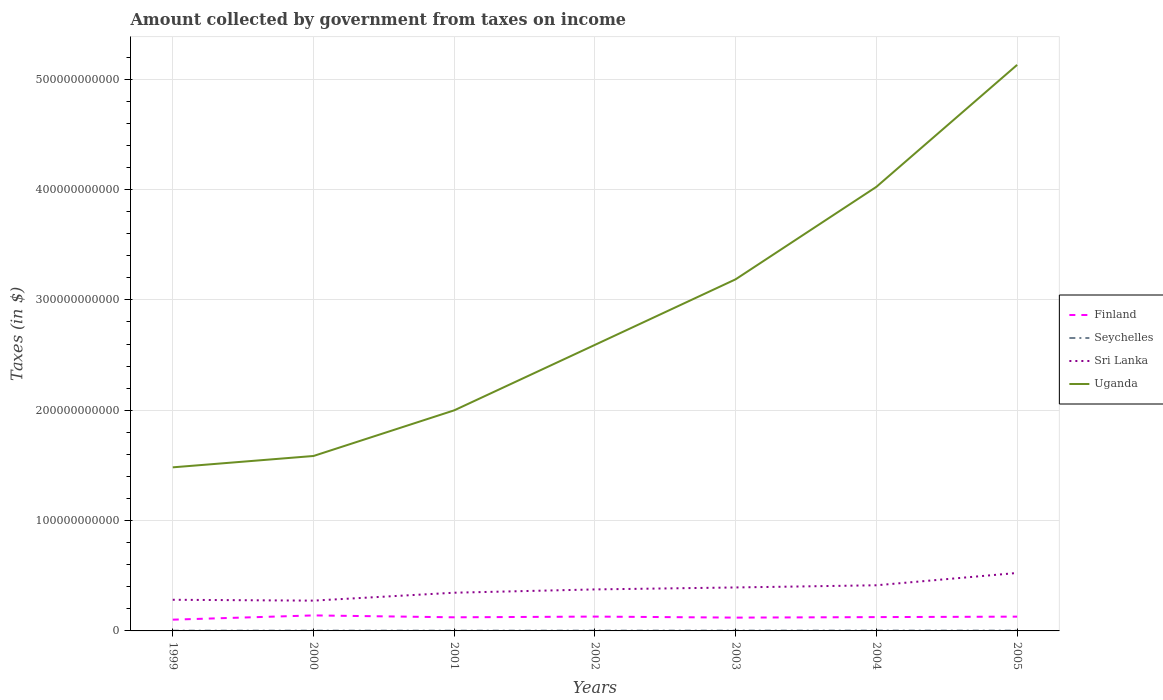Does the line corresponding to Uganda intersect with the line corresponding to Seychelles?
Provide a succinct answer. No. Across all years, what is the maximum amount collected by government from taxes on income in Finland?
Offer a very short reply. 1.02e+1. In which year was the amount collected by government from taxes on income in Sri Lanka maximum?
Keep it short and to the point. 2000. What is the total amount collected by government from taxes on income in Sri Lanka in the graph?
Offer a terse response. -9.39e+09. What is the difference between the highest and the second highest amount collected by government from taxes on income in Seychelles?
Make the answer very short. 7.53e+07. What is the difference between two consecutive major ticks on the Y-axis?
Provide a short and direct response. 1.00e+11. Where does the legend appear in the graph?
Ensure brevity in your answer.  Center right. What is the title of the graph?
Your answer should be very brief. Amount collected by government from taxes on income. What is the label or title of the X-axis?
Keep it short and to the point. Years. What is the label or title of the Y-axis?
Offer a terse response. Taxes (in $). What is the Taxes (in $) in Finland in 1999?
Give a very brief answer. 1.02e+1. What is the Taxes (in $) in Seychelles in 1999?
Offer a very short reply. 2.23e+08. What is the Taxes (in $) of Sri Lanka in 1999?
Offer a terse response. 2.82e+1. What is the Taxes (in $) in Uganda in 1999?
Provide a short and direct response. 1.48e+11. What is the Taxes (in $) in Finland in 2000?
Your answer should be compact. 1.41e+1. What is the Taxes (in $) in Seychelles in 2000?
Your response must be concise. 2.44e+08. What is the Taxes (in $) in Sri Lanka in 2000?
Your answer should be compact. 2.75e+1. What is the Taxes (in $) of Uganda in 2000?
Provide a succinct answer. 1.59e+11. What is the Taxes (in $) of Finland in 2001?
Keep it short and to the point. 1.23e+1. What is the Taxes (in $) in Seychelles in 2001?
Keep it short and to the point. 2.28e+08. What is the Taxes (in $) in Sri Lanka in 2001?
Ensure brevity in your answer.  3.46e+1. What is the Taxes (in $) of Uganda in 2001?
Make the answer very short. 2.00e+11. What is the Taxes (in $) of Finland in 2002?
Your response must be concise. 1.30e+1. What is the Taxes (in $) in Seychelles in 2002?
Provide a succinct answer. 2.53e+08. What is the Taxes (in $) in Sri Lanka in 2002?
Your answer should be very brief. 3.76e+1. What is the Taxes (in $) in Uganda in 2002?
Ensure brevity in your answer.  2.59e+11. What is the Taxes (in $) in Finland in 2003?
Your response must be concise. 1.21e+1. What is the Taxes (in $) of Seychelles in 2003?
Your response must be concise. 2.77e+08. What is the Taxes (in $) of Sri Lanka in 2003?
Your answer should be compact. 3.94e+1. What is the Taxes (in $) in Uganda in 2003?
Your answer should be very brief. 3.19e+11. What is the Taxes (in $) of Finland in 2004?
Your response must be concise. 1.25e+1. What is the Taxes (in $) in Seychelles in 2004?
Offer a terse response. 2.98e+08. What is the Taxes (in $) of Sri Lanka in 2004?
Offer a very short reply. 4.14e+1. What is the Taxes (in $) in Uganda in 2004?
Your answer should be very brief. 4.02e+11. What is the Taxes (in $) in Finland in 2005?
Ensure brevity in your answer.  1.29e+1. What is the Taxes (in $) in Seychelles in 2005?
Provide a succinct answer. 2.79e+08. What is the Taxes (in $) in Sri Lanka in 2005?
Give a very brief answer. 5.25e+1. What is the Taxes (in $) in Uganda in 2005?
Make the answer very short. 5.13e+11. Across all years, what is the maximum Taxes (in $) in Finland?
Offer a very short reply. 1.41e+1. Across all years, what is the maximum Taxes (in $) in Seychelles?
Make the answer very short. 2.98e+08. Across all years, what is the maximum Taxes (in $) in Sri Lanka?
Your answer should be very brief. 5.25e+1. Across all years, what is the maximum Taxes (in $) of Uganda?
Give a very brief answer. 5.13e+11. Across all years, what is the minimum Taxes (in $) of Finland?
Give a very brief answer. 1.02e+1. Across all years, what is the minimum Taxes (in $) in Seychelles?
Provide a succinct answer. 2.23e+08. Across all years, what is the minimum Taxes (in $) of Sri Lanka?
Keep it short and to the point. 2.75e+1. Across all years, what is the minimum Taxes (in $) in Uganda?
Provide a succinct answer. 1.48e+11. What is the total Taxes (in $) of Finland in the graph?
Your response must be concise. 8.71e+1. What is the total Taxes (in $) of Seychelles in the graph?
Keep it short and to the point. 1.80e+09. What is the total Taxes (in $) in Sri Lanka in the graph?
Your answer should be very brief. 2.61e+11. What is the total Taxes (in $) in Uganda in the graph?
Offer a very short reply. 2.00e+12. What is the difference between the Taxes (in $) in Finland in 1999 and that in 2000?
Keep it short and to the point. -3.85e+09. What is the difference between the Taxes (in $) in Seychelles in 1999 and that in 2000?
Give a very brief answer. -2.12e+07. What is the difference between the Taxes (in $) of Sri Lanka in 1999 and that in 2000?
Your response must be concise. 7.70e+08. What is the difference between the Taxes (in $) of Uganda in 1999 and that in 2000?
Your response must be concise. -1.03e+1. What is the difference between the Taxes (in $) of Finland in 1999 and that in 2001?
Ensure brevity in your answer.  -2.14e+09. What is the difference between the Taxes (in $) of Seychelles in 1999 and that in 2001?
Your response must be concise. -5.10e+06. What is the difference between the Taxes (in $) in Sri Lanka in 1999 and that in 2001?
Provide a succinct answer. -6.41e+09. What is the difference between the Taxes (in $) of Uganda in 1999 and that in 2001?
Your response must be concise. -5.17e+1. What is the difference between the Taxes (in $) in Finland in 1999 and that in 2002?
Keep it short and to the point. -2.79e+09. What is the difference between the Taxes (in $) in Seychelles in 1999 and that in 2002?
Offer a terse response. -3.00e+07. What is the difference between the Taxes (in $) in Sri Lanka in 1999 and that in 2002?
Offer a terse response. -9.39e+09. What is the difference between the Taxes (in $) in Uganda in 1999 and that in 2002?
Make the answer very short. -1.11e+11. What is the difference between the Taxes (in $) in Finland in 1999 and that in 2003?
Your response must be concise. -1.86e+09. What is the difference between the Taxes (in $) of Seychelles in 1999 and that in 2003?
Offer a terse response. -5.35e+07. What is the difference between the Taxes (in $) in Sri Lanka in 1999 and that in 2003?
Give a very brief answer. -1.12e+1. What is the difference between the Taxes (in $) of Uganda in 1999 and that in 2003?
Your answer should be compact. -1.70e+11. What is the difference between the Taxes (in $) in Finland in 1999 and that in 2004?
Provide a succinct answer. -2.32e+09. What is the difference between the Taxes (in $) in Seychelles in 1999 and that in 2004?
Your answer should be very brief. -7.53e+07. What is the difference between the Taxes (in $) of Sri Lanka in 1999 and that in 2004?
Offer a very short reply. -1.31e+1. What is the difference between the Taxes (in $) in Uganda in 1999 and that in 2004?
Your response must be concise. -2.54e+11. What is the difference between the Taxes (in $) in Finland in 1999 and that in 2005?
Your answer should be very brief. -2.74e+09. What is the difference between the Taxes (in $) in Seychelles in 1999 and that in 2005?
Give a very brief answer. -5.63e+07. What is the difference between the Taxes (in $) in Sri Lanka in 1999 and that in 2005?
Your answer should be compact. -2.43e+1. What is the difference between the Taxes (in $) of Uganda in 1999 and that in 2005?
Make the answer very short. -3.65e+11. What is the difference between the Taxes (in $) of Finland in 2000 and that in 2001?
Offer a very short reply. 1.72e+09. What is the difference between the Taxes (in $) of Seychelles in 2000 and that in 2001?
Your response must be concise. 1.61e+07. What is the difference between the Taxes (in $) of Sri Lanka in 2000 and that in 2001?
Give a very brief answer. -7.18e+09. What is the difference between the Taxes (in $) of Uganda in 2000 and that in 2001?
Provide a short and direct response. -4.14e+1. What is the difference between the Taxes (in $) in Finland in 2000 and that in 2002?
Provide a short and direct response. 1.07e+09. What is the difference between the Taxes (in $) in Seychelles in 2000 and that in 2002?
Ensure brevity in your answer.  -8.80e+06. What is the difference between the Taxes (in $) of Sri Lanka in 2000 and that in 2002?
Offer a very short reply. -1.02e+1. What is the difference between the Taxes (in $) in Uganda in 2000 and that in 2002?
Your response must be concise. -1.01e+11. What is the difference between the Taxes (in $) in Finland in 2000 and that in 2003?
Your response must be concise. 1.99e+09. What is the difference between the Taxes (in $) of Seychelles in 2000 and that in 2003?
Your answer should be compact. -3.23e+07. What is the difference between the Taxes (in $) in Sri Lanka in 2000 and that in 2003?
Your answer should be compact. -1.19e+1. What is the difference between the Taxes (in $) in Uganda in 2000 and that in 2003?
Keep it short and to the point. -1.60e+11. What is the difference between the Taxes (in $) of Finland in 2000 and that in 2004?
Provide a succinct answer. 1.54e+09. What is the difference between the Taxes (in $) in Seychelles in 2000 and that in 2004?
Keep it short and to the point. -5.41e+07. What is the difference between the Taxes (in $) of Sri Lanka in 2000 and that in 2004?
Offer a very short reply. -1.39e+1. What is the difference between the Taxes (in $) in Uganda in 2000 and that in 2004?
Offer a terse response. -2.44e+11. What is the difference between the Taxes (in $) of Finland in 2000 and that in 2005?
Offer a very short reply. 1.12e+09. What is the difference between the Taxes (in $) of Seychelles in 2000 and that in 2005?
Offer a very short reply. -3.51e+07. What is the difference between the Taxes (in $) of Sri Lanka in 2000 and that in 2005?
Offer a very short reply. -2.51e+1. What is the difference between the Taxes (in $) in Uganda in 2000 and that in 2005?
Your answer should be very brief. -3.54e+11. What is the difference between the Taxes (in $) of Finland in 2001 and that in 2002?
Your response must be concise. -6.49e+08. What is the difference between the Taxes (in $) of Seychelles in 2001 and that in 2002?
Your answer should be very brief. -2.49e+07. What is the difference between the Taxes (in $) in Sri Lanka in 2001 and that in 2002?
Offer a terse response. -2.98e+09. What is the difference between the Taxes (in $) in Uganda in 2001 and that in 2002?
Offer a terse response. -5.93e+1. What is the difference between the Taxes (in $) of Finland in 2001 and that in 2003?
Your answer should be compact. 2.74e+08. What is the difference between the Taxes (in $) in Seychelles in 2001 and that in 2003?
Offer a very short reply. -4.84e+07. What is the difference between the Taxes (in $) of Sri Lanka in 2001 and that in 2003?
Your response must be concise. -4.76e+09. What is the difference between the Taxes (in $) of Uganda in 2001 and that in 2003?
Keep it short and to the point. -1.19e+11. What is the difference between the Taxes (in $) in Finland in 2001 and that in 2004?
Offer a very short reply. -1.82e+08. What is the difference between the Taxes (in $) in Seychelles in 2001 and that in 2004?
Make the answer very short. -7.02e+07. What is the difference between the Taxes (in $) in Sri Lanka in 2001 and that in 2004?
Offer a very short reply. -6.74e+09. What is the difference between the Taxes (in $) in Uganda in 2001 and that in 2004?
Offer a terse response. -2.03e+11. What is the difference between the Taxes (in $) in Finland in 2001 and that in 2005?
Your answer should be compact. -6.02e+08. What is the difference between the Taxes (in $) of Seychelles in 2001 and that in 2005?
Provide a short and direct response. -5.12e+07. What is the difference between the Taxes (in $) in Sri Lanka in 2001 and that in 2005?
Give a very brief answer. -1.79e+1. What is the difference between the Taxes (in $) in Uganda in 2001 and that in 2005?
Keep it short and to the point. -3.13e+11. What is the difference between the Taxes (in $) of Finland in 2002 and that in 2003?
Your answer should be compact. 9.24e+08. What is the difference between the Taxes (in $) of Seychelles in 2002 and that in 2003?
Provide a short and direct response. -2.35e+07. What is the difference between the Taxes (in $) in Sri Lanka in 2002 and that in 2003?
Provide a short and direct response. -1.78e+09. What is the difference between the Taxes (in $) of Uganda in 2002 and that in 2003?
Give a very brief answer. -5.94e+1. What is the difference between the Taxes (in $) in Finland in 2002 and that in 2004?
Your answer should be very brief. 4.68e+08. What is the difference between the Taxes (in $) in Seychelles in 2002 and that in 2004?
Offer a very short reply. -4.53e+07. What is the difference between the Taxes (in $) in Sri Lanka in 2002 and that in 2004?
Provide a succinct answer. -3.75e+09. What is the difference between the Taxes (in $) in Uganda in 2002 and that in 2004?
Your answer should be compact. -1.43e+11. What is the difference between the Taxes (in $) in Finland in 2002 and that in 2005?
Give a very brief answer. 4.75e+07. What is the difference between the Taxes (in $) of Seychelles in 2002 and that in 2005?
Keep it short and to the point. -2.63e+07. What is the difference between the Taxes (in $) in Sri Lanka in 2002 and that in 2005?
Offer a very short reply. -1.49e+1. What is the difference between the Taxes (in $) in Uganda in 2002 and that in 2005?
Your answer should be very brief. -2.54e+11. What is the difference between the Taxes (in $) of Finland in 2003 and that in 2004?
Make the answer very short. -4.56e+08. What is the difference between the Taxes (in $) in Seychelles in 2003 and that in 2004?
Offer a very short reply. -2.18e+07. What is the difference between the Taxes (in $) of Sri Lanka in 2003 and that in 2004?
Offer a very short reply. -1.98e+09. What is the difference between the Taxes (in $) of Uganda in 2003 and that in 2004?
Your answer should be compact. -8.38e+1. What is the difference between the Taxes (in $) of Finland in 2003 and that in 2005?
Provide a succinct answer. -8.76e+08. What is the difference between the Taxes (in $) of Seychelles in 2003 and that in 2005?
Your answer should be very brief. -2.84e+06. What is the difference between the Taxes (in $) in Sri Lanka in 2003 and that in 2005?
Provide a succinct answer. -1.31e+1. What is the difference between the Taxes (in $) in Uganda in 2003 and that in 2005?
Offer a very short reply. -1.94e+11. What is the difference between the Taxes (in $) in Finland in 2004 and that in 2005?
Offer a very short reply. -4.20e+08. What is the difference between the Taxes (in $) in Seychelles in 2004 and that in 2005?
Give a very brief answer. 1.90e+07. What is the difference between the Taxes (in $) of Sri Lanka in 2004 and that in 2005?
Offer a terse response. -1.12e+1. What is the difference between the Taxes (in $) in Uganda in 2004 and that in 2005?
Your response must be concise. -1.11e+11. What is the difference between the Taxes (in $) in Finland in 1999 and the Taxes (in $) in Seychelles in 2000?
Provide a short and direct response. 9.96e+09. What is the difference between the Taxes (in $) of Finland in 1999 and the Taxes (in $) of Sri Lanka in 2000?
Offer a terse response. -1.73e+1. What is the difference between the Taxes (in $) in Finland in 1999 and the Taxes (in $) in Uganda in 2000?
Offer a terse response. -1.48e+11. What is the difference between the Taxes (in $) of Seychelles in 1999 and the Taxes (in $) of Sri Lanka in 2000?
Your answer should be compact. -2.72e+1. What is the difference between the Taxes (in $) in Seychelles in 1999 and the Taxes (in $) in Uganda in 2000?
Ensure brevity in your answer.  -1.58e+11. What is the difference between the Taxes (in $) of Sri Lanka in 1999 and the Taxes (in $) of Uganda in 2000?
Keep it short and to the point. -1.30e+11. What is the difference between the Taxes (in $) in Finland in 1999 and the Taxes (in $) in Seychelles in 2001?
Provide a short and direct response. 9.98e+09. What is the difference between the Taxes (in $) of Finland in 1999 and the Taxes (in $) of Sri Lanka in 2001?
Ensure brevity in your answer.  -2.44e+1. What is the difference between the Taxes (in $) of Finland in 1999 and the Taxes (in $) of Uganda in 2001?
Ensure brevity in your answer.  -1.90e+11. What is the difference between the Taxes (in $) of Seychelles in 1999 and the Taxes (in $) of Sri Lanka in 2001?
Provide a short and direct response. -3.44e+1. What is the difference between the Taxes (in $) in Seychelles in 1999 and the Taxes (in $) in Uganda in 2001?
Offer a very short reply. -2.00e+11. What is the difference between the Taxes (in $) of Sri Lanka in 1999 and the Taxes (in $) of Uganda in 2001?
Give a very brief answer. -1.72e+11. What is the difference between the Taxes (in $) of Finland in 1999 and the Taxes (in $) of Seychelles in 2002?
Offer a terse response. 9.95e+09. What is the difference between the Taxes (in $) in Finland in 1999 and the Taxes (in $) in Sri Lanka in 2002?
Offer a very short reply. -2.74e+1. What is the difference between the Taxes (in $) in Finland in 1999 and the Taxes (in $) in Uganda in 2002?
Offer a terse response. -2.49e+11. What is the difference between the Taxes (in $) of Seychelles in 1999 and the Taxes (in $) of Sri Lanka in 2002?
Provide a succinct answer. -3.74e+1. What is the difference between the Taxes (in $) of Seychelles in 1999 and the Taxes (in $) of Uganda in 2002?
Offer a very short reply. -2.59e+11. What is the difference between the Taxes (in $) in Sri Lanka in 1999 and the Taxes (in $) in Uganda in 2002?
Offer a terse response. -2.31e+11. What is the difference between the Taxes (in $) in Finland in 1999 and the Taxes (in $) in Seychelles in 2003?
Offer a terse response. 9.93e+09. What is the difference between the Taxes (in $) in Finland in 1999 and the Taxes (in $) in Sri Lanka in 2003?
Ensure brevity in your answer.  -2.92e+1. What is the difference between the Taxes (in $) in Finland in 1999 and the Taxes (in $) in Uganda in 2003?
Offer a very short reply. -3.09e+11. What is the difference between the Taxes (in $) in Seychelles in 1999 and the Taxes (in $) in Sri Lanka in 2003?
Your answer should be compact. -3.92e+1. What is the difference between the Taxes (in $) in Seychelles in 1999 and the Taxes (in $) in Uganda in 2003?
Make the answer very short. -3.18e+11. What is the difference between the Taxes (in $) in Sri Lanka in 1999 and the Taxes (in $) in Uganda in 2003?
Offer a very short reply. -2.90e+11. What is the difference between the Taxes (in $) in Finland in 1999 and the Taxes (in $) in Seychelles in 2004?
Provide a short and direct response. 9.91e+09. What is the difference between the Taxes (in $) in Finland in 1999 and the Taxes (in $) in Sri Lanka in 2004?
Keep it short and to the point. -3.12e+1. What is the difference between the Taxes (in $) in Finland in 1999 and the Taxes (in $) in Uganda in 2004?
Make the answer very short. -3.92e+11. What is the difference between the Taxes (in $) in Seychelles in 1999 and the Taxes (in $) in Sri Lanka in 2004?
Your answer should be very brief. -4.11e+1. What is the difference between the Taxes (in $) of Seychelles in 1999 and the Taxes (in $) of Uganda in 2004?
Offer a terse response. -4.02e+11. What is the difference between the Taxes (in $) of Sri Lanka in 1999 and the Taxes (in $) of Uganda in 2004?
Your answer should be compact. -3.74e+11. What is the difference between the Taxes (in $) in Finland in 1999 and the Taxes (in $) in Seychelles in 2005?
Offer a terse response. 9.93e+09. What is the difference between the Taxes (in $) in Finland in 1999 and the Taxes (in $) in Sri Lanka in 2005?
Give a very brief answer. -4.23e+1. What is the difference between the Taxes (in $) of Finland in 1999 and the Taxes (in $) of Uganda in 2005?
Give a very brief answer. -5.03e+11. What is the difference between the Taxes (in $) in Seychelles in 1999 and the Taxes (in $) in Sri Lanka in 2005?
Your response must be concise. -5.23e+1. What is the difference between the Taxes (in $) in Seychelles in 1999 and the Taxes (in $) in Uganda in 2005?
Your response must be concise. -5.13e+11. What is the difference between the Taxes (in $) in Sri Lanka in 1999 and the Taxes (in $) in Uganda in 2005?
Your response must be concise. -4.85e+11. What is the difference between the Taxes (in $) in Finland in 2000 and the Taxes (in $) in Seychelles in 2001?
Offer a terse response. 1.38e+1. What is the difference between the Taxes (in $) of Finland in 2000 and the Taxes (in $) of Sri Lanka in 2001?
Your answer should be very brief. -2.06e+1. What is the difference between the Taxes (in $) of Finland in 2000 and the Taxes (in $) of Uganda in 2001?
Your answer should be very brief. -1.86e+11. What is the difference between the Taxes (in $) in Seychelles in 2000 and the Taxes (in $) in Sri Lanka in 2001?
Offer a very short reply. -3.44e+1. What is the difference between the Taxes (in $) in Seychelles in 2000 and the Taxes (in $) in Uganda in 2001?
Your response must be concise. -2.00e+11. What is the difference between the Taxes (in $) in Sri Lanka in 2000 and the Taxes (in $) in Uganda in 2001?
Provide a succinct answer. -1.72e+11. What is the difference between the Taxes (in $) of Finland in 2000 and the Taxes (in $) of Seychelles in 2002?
Provide a short and direct response. 1.38e+1. What is the difference between the Taxes (in $) of Finland in 2000 and the Taxes (in $) of Sri Lanka in 2002?
Your answer should be compact. -2.36e+1. What is the difference between the Taxes (in $) in Finland in 2000 and the Taxes (in $) in Uganda in 2002?
Keep it short and to the point. -2.45e+11. What is the difference between the Taxes (in $) in Seychelles in 2000 and the Taxes (in $) in Sri Lanka in 2002?
Provide a short and direct response. -3.74e+1. What is the difference between the Taxes (in $) of Seychelles in 2000 and the Taxes (in $) of Uganda in 2002?
Offer a terse response. -2.59e+11. What is the difference between the Taxes (in $) of Sri Lanka in 2000 and the Taxes (in $) of Uganda in 2002?
Your answer should be compact. -2.32e+11. What is the difference between the Taxes (in $) in Finland in 2000 and the Taxes (in $) in Seychelles in 2003?
Provide a succinct answer. 1.38e+1. What is the difference between the Taxes (in $) in Finland in 2000 and the Taxes (in $) in Sri Lanka in 2003?
Provide a succinct answer. -2.53e+1. What is the difference between the Taxes (in $) in Finland in 2000 and the Taxes (in $) in Uganda in 2003?
Your answer should be compact. -3.05e+11. What is the difference between the Taxes (in $) in Seychelles in 2000 and the Taxes (in $) in Sri Lanka in 2003?
Offer a very short reply. -3.92e+1. What is the difference between the Taxes (in $) in Seychelles in 2000 and the Taxes (in $) in Uganda in 2003?
Your response must be concise. -3.18e+11. What is the difference between the Taxes (in $) in Sri Lanka in 2000 and the Taxes (in $) in Uganda in 2003?
Your response must be concise. -2.91e+11. What is the difference between the Taxes (in $) in Finland in 2000 and the Taxes (in $) in Seychelles in 2004?
Keep it short and to the point. 1.38e+1. What is the difference between the Taxes (in $) of Finland in 2000 and the Taxes (in $) of Sri Lanka in 2004?
Provide a succinct answer. -2.73e+1. What is the difference between the Taxes (in $) in Finland in 2000 and the Taxes (in $) in Uganda in 2004?
Give a very brief answer. -3.88e+11. What is the difference between the Taxes (in $) of Seychelles in 2000 and the Taxes (in $) of Sri Lanka in 2004?
Make the answer very short. -4.11e+1. What is the difference between the Taxes (in $) in Seychelles in 2000 and the Taxes (in $) in Uganda in 2004?
Your answer should be compact. -4.02e+11. What is the difference between the Taxes (in $) in Sri Lanka in 2000 and the Taxes (in $) in Uganda in 2004?
Your answer should be very brief. -3.75e+11. What is the difference between the Taxes (in $) of Finland in 2000 and the Taxes (in $) of Seychelles in 2005?
Keep it short and to the point. 1.38e+1. What is the difference between the Taxes (in $) in Finland in 2000 and the Taxes (in $) in Sri Lanka in 2005?
Offer a terse response. -3.85e+1. What is the difference between the Taxes (in $) of Finland in 2000 and the Taxes (in $) of Uganda in 2005?
Offer a terse response. -4.99e+11. What is the difference between the Taxes (in $) of Seychelles in 2000 and the Taxes (in $) of Sri Lanka in 2005?
Give a very brief answer. -5.23e+1. What is the difference between the Taxes (in $) in Seychelles in 2000 and the Taxes (in $) in Uganda in 2005?
Your answer should be compact. -5.13e+11. What is the difference between the Taxes (in $) of Sri Lanka in 2000 and the Taxes (in $) of Uganda in 2005?
Your answer should be very brief. -4.86e+11. What is the difference between the Taxes (in $) in Finland in 2001 and the Taxes (in $) in Seychelles in 2002?
Ensure brevity in your answer.  1.21e+1. What is the difference between the Taxes (in $) in Finland in 2001 and the Taxes (in $) in Sri Lanka in 2002?
Offer a very short reply. -2.53e+1. What is the difference between the Taxes (in $) in Finland in 2001 and the Taxes (in $) in Uganda in 2002?
Give a very brief answer. -2.47e+11. What is the difference between the Taxes (in $) in Seychelles in 2001 and the Taxes (in $) in Sri Lanka in 2002?
Offer a very short reply. -3.74e+1. What is the difference between the Taxes (in $) of Seychelles in 2001 and the Taxes (in $) of Uganda in 2002?
Ensure brevity in your answer.  -2.59e+11. What is the difference between the Taxes (in $) in Sri Lanka in 2001 and the Taxes (in $) in Uganda in 2002?
Provide a short and direct response. -2.25e+11. What is the difference between the Taxes (in $) in Finland in 2001 and the Taxes (in $) in Seychelles in 2003?
Your answer should be compact. 1.21e+1. What is the difference between the Taxes (in $) in Finland in 2001 and the Taxes (in $) in Sri Lanka in 2003?
Provide a succinct answer. -2.71e+1. What is the difference between the Taxes (in $) in Finland in 2001 and the Taxes (in $) in Uganda in 2003?
Your response must be concise. -3.06e+11. What is the difference between the Taxes (in $) in Seychelles in 2001 and the Taxes (in $) in Sri Lanka in 2003?
Make the answer very short. -3.92e+1. What is the difference between the Taxes (in $) of Seychelles in 2001 and the Taxes (in $) of Uganda in 2003?
Ensure brevity in your answer.  -3.18e+11. What is the difference between the Taxes (in $) of Sri Lanka in 2001 and the Taxes (in $) of Uganda in 2003?
Offer a terse response. -2.84e+11. What is the difference between the Taxes (in $) in Finland in 2001 and the Taxes (in $) in Seychelles in 2004?
Your answer should be very brief. 1.20e+1. What is the difference between the Taxes (in $) of Finland in 2001 and the Taxes (in $) of Sri Lanka in 2004?
Ensure brevity in your answer.  -2.90e+1. What is the difference between the Taxes (in $) of Finland in 2001 and the Taxes (in $) of Uganda in 2004?
Provide a succinct answer. -3.90e+11. What is the difference between the Taxes (in $) of Seychelles in 2001 and the Taxes (in $) of Sri Lanka in 2004?
Offer a very short reply. -4.11e+1. What is the difference between the Taxes (in $) of Seychelles in 2001 and the Taxes (in $) of Uganda in 2004?
Ensure brevity in your answer.  -4.02e+11. What is the difference between the Taxes (in $) of Sri Lanka in 2001 and the Taxes (in $) of Uganda in 2004?
Keep it short and to the point. -3.68e+11. What is the difference between the Taxes (in $) in Finland in 2001 and the Taxes (in $) in Seychelles in 2005?
Give a very brief answer. 1.21e+1. What is the difference between the Taxes (in $) of Finland in 2001 and the Taxes (in $) of Sri Lanka in 2005?
Your answer should be compact. -4.02e+1. What is the difference between the Taxes (in $) of Finland in 2001 and the Taxes (in $) of Uganda in 2005?
Give a very brief answer. -5.01e+11. What is the difference between the Taxes (in $) of Seychelles in 2001 and the Taxes (in $) of Sri Lanka in 2005?
Keep it short and to the point. -5.23e+1. What is the difference between the Taxes (in $) in Seychelles in 2001 and the Taxes (in $) in Uganda in 2005?
Ensure brevity in your answer.  -5.13e+11. What is the difference between the Taxes (in $) of Sri Lanka in 2001 and the Taxes (in $) of Uganda in 2005?
Give a very brief answer. -4.78e+11. What is the difference between the Taxes (in $) of Finland in 2002 and the Taxes (in $) of Seychelles in 2003?
Keep it short and to the point. 1.27e+1. What is the difference between the Taxes (in $) of Finland in 2002 and the Taxes (in $) of Sri Lanka in 2003?
Offer a terse response. -2.64e+1. What is the difference between the Taxes (in $) of Finland in 2002 and the Taxes (in $) of Uganda in 2003?
Provide a succinct answer. -3.06e+11. What is the difference between the Taxes (in $) in Seychelles in 2002 and the Taxes (in $) in Sri Lanka in 2003?
Provide a short and direct response. -3.91e+1. What is the difference between the Taxes (in $) in Seychelles in 2002 and the Taxes (in $) in Uganda in 2003?
Your response must be concise. -3.18e+11. What is the difference between the Taxes (in $) of Sri Lanka in 2002 and the Taxes (in $) of Uganda in 2003?
Provide a succinct answer. -2.81e+11. What is the difference between the Taxes (in $) in Finland in 2002 and the Taxes (in $) in Seychelles in 2004?
Ensure brevity in your answer.  1.27e+1. What is the difference between the Taxes (in $) in Finland in 2002 and the Taxes (in $) in Sri Lanka in 2004?
Make the answer very short. -2.84e+1. What is the difference between the Taxes (in $) in Finland in 2002 and the Taxes (in $) in Uganda in 2004?
Offer a terse response. -3.90e+11. What is the difference between the Taxes (in $) in Seychelles in 2002 and the Taxes (in $) in Sri Lanka in 2004?
Offer a terse response. -4.11e+1. What is the difference between the Taxes (in $) in Seychelles in 2002 and the Taxes (in $) in Uganda in 2004?
Offer a very short reply. -4.02e+11. What is the difference between the Taxes (in $) in Sri Lanka in 2002 and the Taxes (in $) in Uganda in 2004?
Offer a very short reply. -3.65e+11. What is the difference between the Taxes (in $) of Finland in 2002 and the Taxes (in $) of Seychelles in 2005?
Make the answer very short. 1.27e+1. What is the difference between the Taxes (in $) in Finland in 2002 and the Taxes (in $) in Sri Lanka in 2005?
Your answer should be compact. -3.95e+1. What is the difference between the Taxes (in $) of Finland in 2002 and the Taxes (in $) of Uganda in 2005?
Your answer should be compact. -5.00e+11. What is the difference between the Taxes (in $) of Seychelles in 2002 and the Taxes (in $) of Sri Lanka in 2005?
Provide a succinct answer. -5.23e+1. What is the difference between the Taxes (in $) in Seychelles in 2002 and the Taxes (in $) in Uganda in 2005?
Your answer should be compact. -5.13e+11. What is the difference between the Taxes (in $) of Sri Lanka in 2002 and the Taxes (in $) of Uganda in 2005?
Offer a terse response. -4.75e+11. What is the difference between the Taxes (in $) in Finland in 2003 and the Taxes (in $) in Seychelles in 2004?
Your answer should be very brief. 1.18e+1. What is the difference between the Taxes (in $) in Finland in 2003 and the Taxes (in $) in Sri Lanka in 2004?
Your answer should be compact. -2.93e+1. What is the difference between the Taxes (in $) in Finland in 2003 and the Taxes (in $) in Uganda in 2004?
Give a very brief answer. -3.90e+11. What is the difference between the Taxes (in $) of Seychelles in 2003 and the Taxes (in $) of Sri Lanka in 2004?
Your answer should be compact. -4.11e+1. What is the difference between the Taxes (in $) of Seychelles in 2003 and the Taxes (in $) of Uganda in 2004?
Provide a short and direct response. -4.02e+11. What is the difference between the Taxes (in $) in Sri Lanka in 2003 and the Taxes (in $) in Uganda in 2004?
Your answer should be compact. -3.63e+11. What is the difference between the Taxes (in $) of Finland in 2003 and the Taxes (in $) of Seychelles in 2005?
Your answer should be compact. 1.18e+1. What is the difference between the Taxes (in $) of Finland in 2003 and the Taxes (in $) of Sri Lanka in 2005?
Make the answer very short. -4.05e+1. What is the difference between the Taxes (in $) of Finland in 2003 and the Taxes (in $) of Uganda in 2005?
Provide a short and direct response. -5.01e+11. What is the difference between the Taxes (in $) of Seychelles in 2003 and the Taxes (in $) of Sri Lanka in 2005?
Give a very brief answer. -5.23e+1. What is the difference between the Taxes (in $) of Seychelles in 2003 and the Taxes (in $) of Uganda in 2005?
Your answer should be very brief. -5.13e+11. What is the difference between the Taxes (in $) in Sri Lanka in 2003 and the Taxes (in $) in Uganda in 2005?
Give a very brief answer. -4.74e+11. What is the difference between the Taxes (in $) in Finland in 2004 and the Taxes (in $) in Seychelles in 2005?
Keep it short and to the point. 1.22e+1. What is the difference between the Taxes (in $) in Finland in 2004 and the Taxes (in $) in Sri Lanka in 2005?
Your answer should be very brief. -4.00e+1. What is the difference between the Taxes (in $) of Finland in 2004 and the Taxes (in $) of Uganda in 2005?
Provide a short and direct response. -5.01e+11. What is the difference between the Taxes (in $) of Seychelles in 2004 and the Taxes (in $) of Sri Lanka in 2005?
Offer a very short reply. -5.22e+1. What is the difference between the Taxes (in $) in Seychelles in 2004 and the Taxes (in $) in Uganda in 2005?
Your answer should be very brief. -5.13e+11. What is the difference between the Taxes (in $) of Sri Lanka in 2004 and the Taxes (in $) of Uganda in 2005?
Make the answer very short. -4.72e+11. What is the average Taxes (in $) in Finland per year?
Provide a short and direct response. 1.24e+1. What is the average Taxes (in $) of Seychelles per year?
Offer a terse response. 2.58e+08. What is the average Taxes (in $) of Sri Lanka per year?
Ensure brevity in your answer.  3.73e+1. What is the average Taxes (in $) in Uganda per year?
Ensure brevity in your answer.  2.86e+11. In the year 1999, what is the difference between the Taxes (in $) of Finland and Taxes (in $) of Seychelles?
Ensure brevity in your answer.  9.98e+09. In the year 1999, what is the difference between the Taxes (in $) of Finland and Taxes (in $) of Sri Lanka?
Your response must be concise. -1.80e+1. In the year 1999, what is the difference between the Taxes (in $) of Finland and Taxes (in $) of Uganda?
Give a very brief answer. -1.38e+11. In the year 1999, what is the difference between the Taxes (in $) in Seychelles and Taxes (in $) in Sri Lanka?
Your answer should be compact. -2.80e+1. In the year 1999, what is the difference between the Taxes (in $) in Seychelles and Taxes (in $) in Uganda?
Your answer should be compact. -1.48e+11. In the year 1999, what is the difference between the Taxes (in $) of Sri Lanka and Taxes (in $) of Uganda?
Your answer should be very brief. -1.20e+11. In the year 2000, what is the difference between the Taxes (in $) of Finland and Taxes (in $) of Seychelles?
Keep it short and to the point. 1.38e+1. In the year 2000, what is the difference between the Taxes (in $) of Finland and Taxes (in $) of Sri Lanka?
Your answer should be very brief. -1.34e+1. In the year 2000, what is the difference between the Taxes (in $) of Finland and Taxes (in $) of Uganda?
Your answer should be compact. -1.44e+11. In the year 2000, what is the difference between the Taxes (in $) in Seychelles and Taxes (in $) in Sri Lanka?
Your answer should be compact. -2.72e+1. In the year 2000, what is the difference between the Taxes (in $) in Seychelles and Taxes (in $) in Uganda?
Your answer should be compact. -1.58e+11. In the year 2000, what is the difference between the Taxes (in $) of Sri Lanka and Taxes (in $) of Uganda?
Provide a short and direct response. -1.31e+11. In the year 2001, what is the difference between the Taxes (in $) of Finland and Taxes (in $) of Seychelles?
Provide a succinct answer. 1.21e+1. In the year 2001, what is the difference between the Taxes (in $) in Finland and Taxes (in $) in Sri Lanka?
Offer a very short reply. -2.23e+1. In the year 2001, what is the difference between the Taxes (in $) in Finland and Taxes (in $) in Uganda?
Offer a very short reply. -1.88e+11. In the year 2001, what is the difference between the Taxes (in $) in Seychelles and Taxes (in $) in Sri Lanka?
Your answer should be compact. -3.44e+1. In the year 2001, what is the difference between the Taxes (in $) in Seychelles and Taxes (in $) in Uganda?
Ensure brevity in your answer.  -2.00e+11. In the year 2001, what is the difference between the Taxes (in $) of Sri Lanka and Taxes (in $) of Uganda?
Make the answer very short. -1.65e+11. In the year 2002, what is the difference between the Taxes (in $) of Finland and Taxes (in $) of Seychelles?
Make the answer very short. 1.27e+1. In the year 2002, what is the difference between the Taxes (in $) of Finland and Taxes (in $) of Sri Lanka?
Your answer should be very brief. -2.46e+1. In the year 2002, what is the difference between the Taxes (in $) of Finland and Taxes (in $) of Uganda?
Provide a short and direct response. -2.46e+11. In the year 2002, what is the difference between the Taxes (in $) of Seychelles and Taxes (in $) of Sri Lanka?
Your answer should be very brief. -3.74e+1. In the year 2002, what is the difference between the Taxes (in $) in Seychelles and Taxes (in $) in Uganda?
Your answer should be very brief. -2.59e+11. In the year 2002, what is the difference between the Taxes (in $) in Sri Lanka and Taxes (in $) in Uganda?
Your answer should be very brief. -2.22e+11. In the year 2003, what is the difference between the Taxes (in $) in Finland and Taxes (in $) in Seychelles?
Offer a terse response. 1.18e+1. In the year 2003, what is the difference between the Taxes (in $) of Finland and Taxes (in $) of Sri Lanka?
Offer a terse response. -2.73e+1. In the year 2003, what is the difference between the Taxes (in $) in Finland and Taxes (in $) in Uganda?
Your answer should be compact. -3.07e+11. In the year 2003, what is the difference between the Taxes (in $) in Seychelles and Taxes (in $) in Sri Lanka?
Make the answer very short. -3.91e+1. In the year 2003, what is the difference between the Taxes (in $) of Seychelles and Taxes (in $) of Uganda?
Provide a succinct answer. -3.18e+11. In the year 2003, what is the difference between the Taxes (in $) in Sri Lanka and Taxes (in $) in Uganda?
Ensure brevity in your answer.  -2.79e+11. In the year 2004, what is the difference between the Taxes (in $) of Finland and Taxes (in $) of Seychelles?
Provide a succinct answer. 1.22e+1. In the year 2004, what is the difference between the Taxes (in $) of Finland and Taxes (in $) of Sri Lanka?
Your answer should be compact. -2.88e+1. In the year 2004, what is the difference between the Taxes (in $) in Finland and Taxes (in $) in Uganda?
Offer a very short reply. -3.90e+11. In the year 2004, what is the difference between the Taxes (in $) in Seychelles and Taxes (in $) in Sri Lanka?
Provide a short and direct response. -4.11e+1. In the year 2004, what is the difference between the Taxes (in $) of Seychelles and Taxes (in $) of Uganda?
Provide a succinct answer. -4.02e+11. In the year 2004, what is the difference between the Taxes (in $) in Sri Lanka and Taxes (in $) in Uganda?
Offer a terse response. -3.61e+11. In the year 2005, what is the difference between the Taxes (in $) of Finland and Taxes (in $) of Seychelles?
Your answer should be compact. 1.27e+1. In the year 2005, what is the difference between the Taxes (in $) of Finland and Taxes (in $) of Sri Lanka?
Your response must be concise. -3.96e+1. In the year 2005, what is the difference between the Taxes (in $) of Finland and Taxes (in $) of Uganda?
Ensure brevity in your answer.  -5.00e+11. In the year 2005, what is the difference between the Taxes (in $) of Seychelles and Taxes (in $) of Sri Lanka?
Provide a short and direct response. -5.23e+1. In the year 2005, what is the difference between the Taxes (in $) in Seychelles and Taxes (in $) in Uganda?
Provide a succinct answer. -5.13e+11. In the year 2005, what is the difference between the Taxes (in $) in Sri Lanka and Taxes (in $) in Uganda?
Ensure brevity in your answer.  -4.61e+11. What is the ratio of the Taxes (in $) of Finland in 1999 to that in 2000?
Provide a succinct answer. 0.73. What is the ratio of the Taxes (in $) in Seychelles in 1999 to that in 2000?
Offer a very short reply. 0.91. What is the ratio of the Taxes (in $) of Sri Lanka in 1999 to that in 2000?
Provide a succinct answer. 1.03. What is the ratio of the Taxes (in $) in Uganda in 1999 to that in 2000?
Your answer should be compact. 0.94. What is the ratio of the Taxes (in $) of Finland in 1999 to that in 2001?
Your answer should be very brief. 0.83. What is the ratio of the Taxes (in $) in Seychelles in 1999 to that in 2001?
Ensure brevity in your answer.  0.98. What is the ratio of the Taxes (in $) of Sri Lanka in 1999 to that in 2001?
Give a very brief answer. 0.81. What is the ratio of the Taxes (in $) in Uganda in 1999 to that in 2001?
Provide a succinct answer. 0.74. What is the ratio of the Taxes (in $) of Finland in 1999 to that in 2002?
Ensure brevity in your answer.  0.79. What is the ratio of the Taxes (in $) in Seychelles in 1999 to that in 2002?
Your answer should be compact. 0.88. What is the ratio of the Taxes (in $) of Sri Lanka in 1999 to that in 2002?
Ensure brevity in your answer.  0.75. What is the ratio of the Taxes (in $) in Uganda in 1999 to that in 2002?
Provide a short and direct response. 0.57. What is the ratio of the Taxes (in $) in Finland in 1999 to that in 2003?
Keep it short and to the point. 0.85. What is the ratio of the Taxes (in $) in Seychelles in 1999 to that in 2003?
Give a very brief answer. 0.81. What is the ratio of the Taxes (in $) in Sri Lanka in 1999 to that in 2003?
Your answer should be compact. 0.72. What is the ratio of the Taxes (in $) in Uganda in 1999 to that in 2003?
Keep it short and to the point. 0.47. What is the ratio of the Taxes (in $) of Finland in 1999 to that in 2004?
Give a very brief answer. 0.81. What is the ratio of the Taxes (in $) in Seychelles in 1999 to that in 2004?
Ensure brevity in your answer.  0.75. What is the ratio of the Taxes (in $) of Sri Lanka in 1999 to that in 2004?
Ensure brevity in your answer.  0.68. What is the ratio of the Taxes (in $) in Uganda in 1999 to that in 2004?
Provide a short and direct response. 0.37. What is the ratio of the Taxes (in $) in Finland in 1999 to that in 2005?
Offer a very short reply. 0.79. What is the ratio of the Taxes (in $) of Seychelles in 1999 to that in 2005?
Give a very brief answer. 0.8. What is the ratio of the Taxes (in $) of Sri Lanka in 1999 to that in 2005?
Your answer should be compact. 0.54. What is the ratio of the Taxes (in $) in Uganda in 1999 to that in 2005?
Offer a very short reply. 0.29. What is the ratio of the Taxes (in $) of Finland in 2000 to that in 2001?
Your answer should be very brief. 1.14. What is the ratio of the Taxes (in $) in Seychelles in 2000 to that in 2001?
Offer a very short reply. 1.07. What is the ratio of the Taxes (in $) in Sri Lanka in 2000 to that in 2001?
Give a very brief answer. 0.79. What is the ratio of the Taxes (in $) in Uganda in 2000 to that in 2001?
Offer a terse response. 0.79. What is the ratio of the Taxes (in $) in Finland in 2000 to that in 2002?
Keep it short and to the point. 1.08. What is the ratio of the Taxes (in $) in Seychelles in 2000 to that in 2002?
Your answer should be very brief. 0.97. What is the ratio of the Taxes (in $) of Sri Lanka in 2000 to that in 2002?
Provide a short and direct response. 0.73. What is the ratio of the Taxes (in $) of Uganda in 2000 to that in 2002?
Give a very brief answer. 0.61. What is the ratio of the Taxes (in $) in Finland in 2000 to that in 2003?
Your answer should be very brief. 1.17. What is the ratio of the Taxes (in $) of Seychelles in 2000 to that in 2003?
Provide a short and direct response. 0.88. What is the ratio of the Taxes (in $) in Sri Lanka in 2000 to that in 2003?
Offer a very short reply. 0.7. What is the ratio of the Taxes (in $) in Uganda in 2000 to that in 2003?
Provide a short and direct response. 0.5. What is the ratio of the Taxes (in $) of Finland in 2000 to that in 2004?
Make the answer very short. 1.12. What is the ratio of the Taxes (in $) in Seychelles in 2000 to that in 2004?
Your answer should be very brief. 0.82. What is the ratio of the Taxes (in $) of Sri Lanka in 2000 to that in 2004?
Your answer should be very brief. 0.66. What is the ratio of the Taxes (in $) in Uganda in 2000 to that in 2004?
Your answer should be compact. 0.39. What is the ratio of the Taxes (in $) of Finland in 2000 to that in 2005?
Your response must be concise. 1.09. What is the ratio of the Taxes (in $) of Seychelles in 2000 to that in 2005?
Your answer should be very brief. 0.87. What is the ratio of the Taxes (in $) in Sri Lanka in 2000 to that in 2005?
Provide a succinct answer. 0.52. What is the ratio of the Taxes (in $) of Uganda in 2000 to that in 2005?
Provide a short and direct response. 0.31. What is the ratio of the Taxes (in $) in Seychelles in 2001 to that in 2002?
Your response must be concise. 0.9. What is the ratio of the Taxes (in $) of Sri Lanka in 2001 to that in 2002?
Ensure brevity in your answer.  0.92. What is the ratio of the Taxes (in $) in Uganda in 2001 to that in 2002?
Provide a succinct answer. 0.77. What is the ratio of the Taxes (in $) of Finland in 2001 to that in 2003?
Your answer should be very brief. 1.02. What is the ratio of the Taxes (in $) in Seychelles in 2001 to that in 2003?
Give a very brief answer. 0.82. What is the ratio of the Taxes (in $) of Sri Lanka in 2001 to that in 2003?
Give a very brief answer. 0.88. What is the ratio of the Taxes (in $) in Uganda in 2001 to that in 2003?
Provide a short and direct response. 0.63. What is the ratio of the Taxes (in $) of Finland in 2001 to that in 2004?
Your response must be concise. 0.99. What is the ratio of the Taxes (in $) of Seychelles in 2001 to that in 2004?
Offer a terse response. 0.76. What is the ratio of the Taxes (in $) of Sri Lanka in 2001 to that in 2004?
Make the answer very short. 0.84. What is the ratio of the Taxes (in $) of Uganda in 2001 to that in 2004?
Make the answer very short. 0.5. What is the ratio of the Taxes (in $) in Finland in 2001 to that in 2005?
Offer a terse response. 0.95. What is the ratio of the Taxes (in $) of Seychelles in 2001 to that in 2005?
Give a very brief answer. 0.82. What is the ratio of the Taxes (in $) of Sri Lanka in 2001 to that in 2005?
Make the answer very short. 0.66. What is the ratio of the Taxes (in $) of Uganda in 2001 to that in 2005?
Your response must be concise. 0.39. What is the ratio of the Taxes (in $) of Finland in 2002 to that in 2003?
Provide a succinct answer. 1.08. What is the ratio of the Taxes (in $) in Seychelles in 2002 to that in 2003?
Keep it short and to the point. 0.92. What is the ratio of the Taxes (in $) of Sri Lanka in 2002 to that in 2003?
Keep it short and to the point. 0.95. What is the ratio of the Taxes (in $) in Uganda in 2002 to that in 2003?
Provide a succinct answer. 0.81. What is the ratio of the Taxes (in $) in Finland in 2002 to that in 2004?
Your response must be concise. 1.04. What is the ratio of the Taxes (in $) in Seychelles in 2002 to that in 2004?
Ensure brevity in your answer.  0.85. What is the ratio of the Taxes (in $) of Sri Lanka in 2002 to that in 2004?
Your response must be concise. 0.91. What is the ratio of the Taxes (in $) in Uganda in 2002 to that in 2004?
Your response must be concise. 0.64. What is the ratio of the Taxes (in $) in Seychelles in 2002 to that in 2005?
Your answer should be compact. 0.91. What is the ratio of the Taxes (in $) in Sri Lanka in 2002 to that in 2005?
Offer a very short reply. 0.72. What is the ratio of the Taxes (in $) of Uganda in 2002 to that in 2005?
Offer a very short reply. 0.51. What is the ratio of the Taxes (in $) of Finland in 2003 to that in 2004?
Provide a short and direct response. 0.96. What is the ratio of the Taxes (in $) of Seychelles in 2003 to that in 2004?
Your answer should be compact. 0.93. What is the ratio of the Taxes (in $) in Sri Lanka in 2003 to that in 2004?
Give a very brief answer. 0.95. What is the ratio of the Taxes (in $) in Uganda in 2003 to that in 2004?
Make the answer very short. 0.79. What is the ratio of the Taxes (in $) in Finland in 2003 to that in 2005?
Your answer should be very brief. 0.93. What is the ratio of the Taxes (in $) of Sri Lanka in 2003 to that in 2005?
Ensure brevity in your answer.  0.75. What is the ratio of the Taxes (in $) in Uganda in 2003 to that in 2005?
Make the answer very short. 0.62. What is the ratio of the Taxes (in $) in Finland in 2004 to that in 2005?
Offer a terse response. 0.97. What is the ratio of the Taxes (in $) of Seychelles in 2004 to that in 2005?
Make the answer very short. 1.07. What is the ratio of the Taxes (in $) in Sri Lanka in 2004 to that in 2005?
Your response must be concise. 0.79. What is the ratio of the Taxes (in $) in Uganda in 2004 to that in 2005?
Provide a succinct answer. 0.78. What is the difference between the highest and the second highest Taxes (in $) of Finland?
Offer a very short reply. 1.07e+09. What is the difference between the highest and the second highest Taxes (in $) of Seychelles?
Keep it short and to the point. 1.90e+07. What is the difference between the highest and the second highest Taxes (in $) of Sri Lanka?
Offer a very short reply. 1.12e+1. What is the difference between the highest and the second highest Taxes (in $) in Uganda?
Provide a succinct answer. 1.11e+11. What is the difference between the highest and the lowest Taxes (in $) of Finland?
Your answer should be very brief. 3.85e+09. What is the difference between the highest and the lowest Taxes (in $) of Seychelles?
Ensure brevity in your answer.  7.53e+07. What is the difference between the highest and the lowest Taxes (in $) of Sri Lanka?
Make the answer very short. 2.51e+1. What is the difference between the highest and the lowest Taxes (in $) in Uganda?
Offer a terse response. 3.65e+11. 